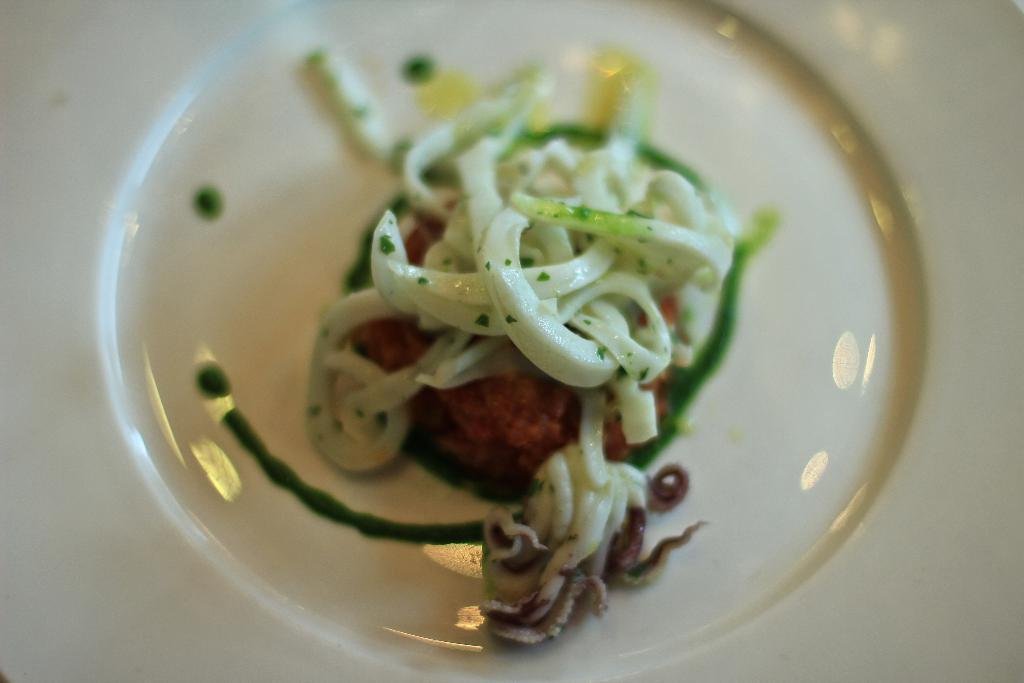In one or two sentences, can you explain what this image depicts? This picture shows food in the glass bowl. 